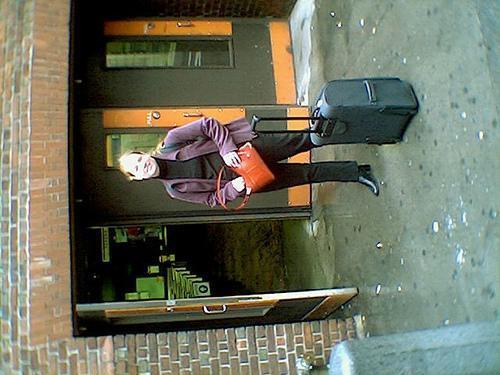How many people are in the photo?
Give a very brief answer. 1. 